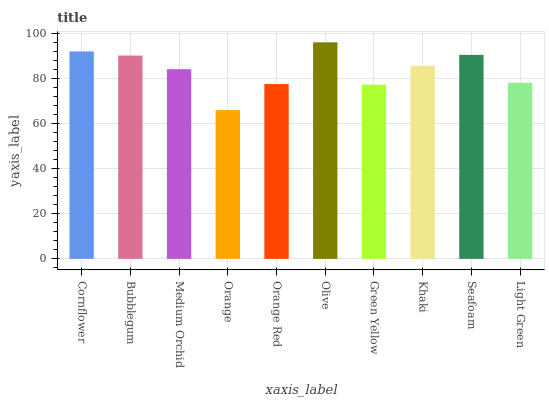Is Orange the minimum?
Answer yes or no. Yes. Is Olive the maximum?
Answer yes or no. Yes. Is Bubblegum the minimum?
Answer yes or no. No. Is Bubblegum the maximum?
Answer yes or no. No. Is Cornflower greater than Bubblegum?
Answer yes or no. Yes. Is Bubblegum less than Cornflower?
Answer yes or no. Yes. Is Bubblegum greater than Cornflower?
Answer yes or no. No. Is Cornflower less than Bubblegum?
Answer yes or no. No. Is Khaki the high median?
Answer yes or no. Yes. Is Medium Orchid the low median?
Answer yes or no. Yes. Is Seafoam the high median?
Answer yes or no. No. Is Orange the low median?
Answer yes or no. No. 